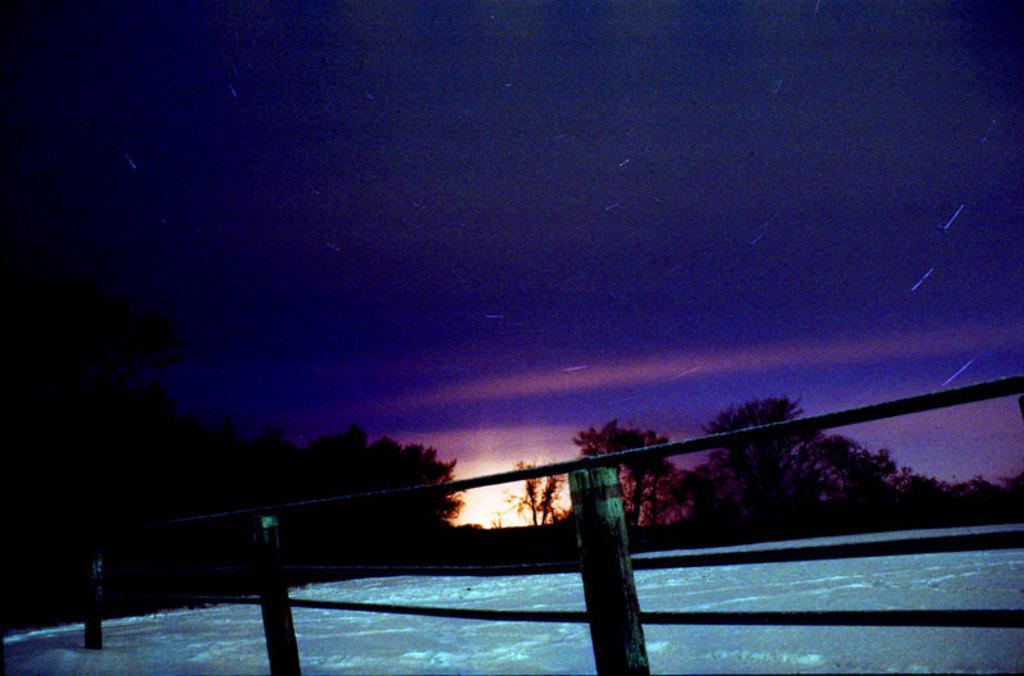Please provide a concise description of this image. In this image we can see snow, fencing, trees, sky and clouds. 